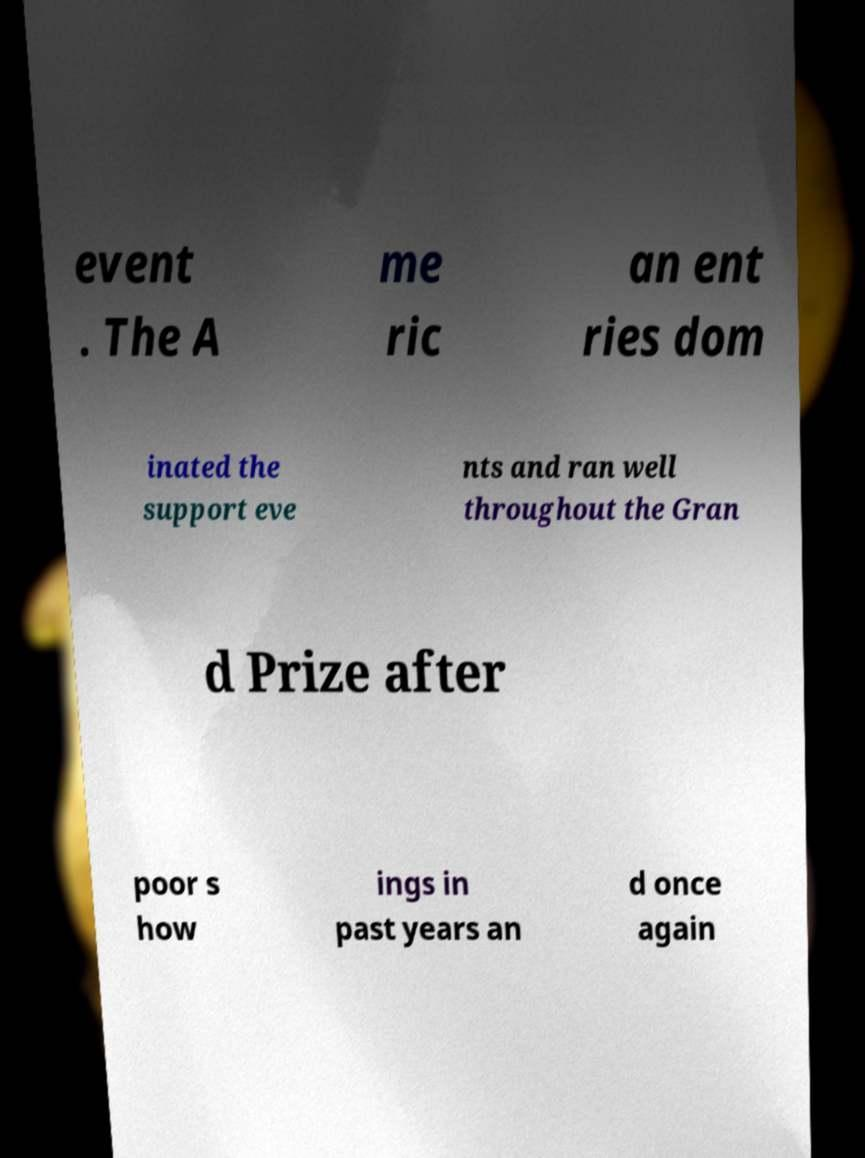Could you assist in decoding the text presented in this image and type it out clearly? event . The A me ric an ent ries dom inated the support eve nts and ran well throughout the Gran d Prize after poor s how ings in past years an d once again 